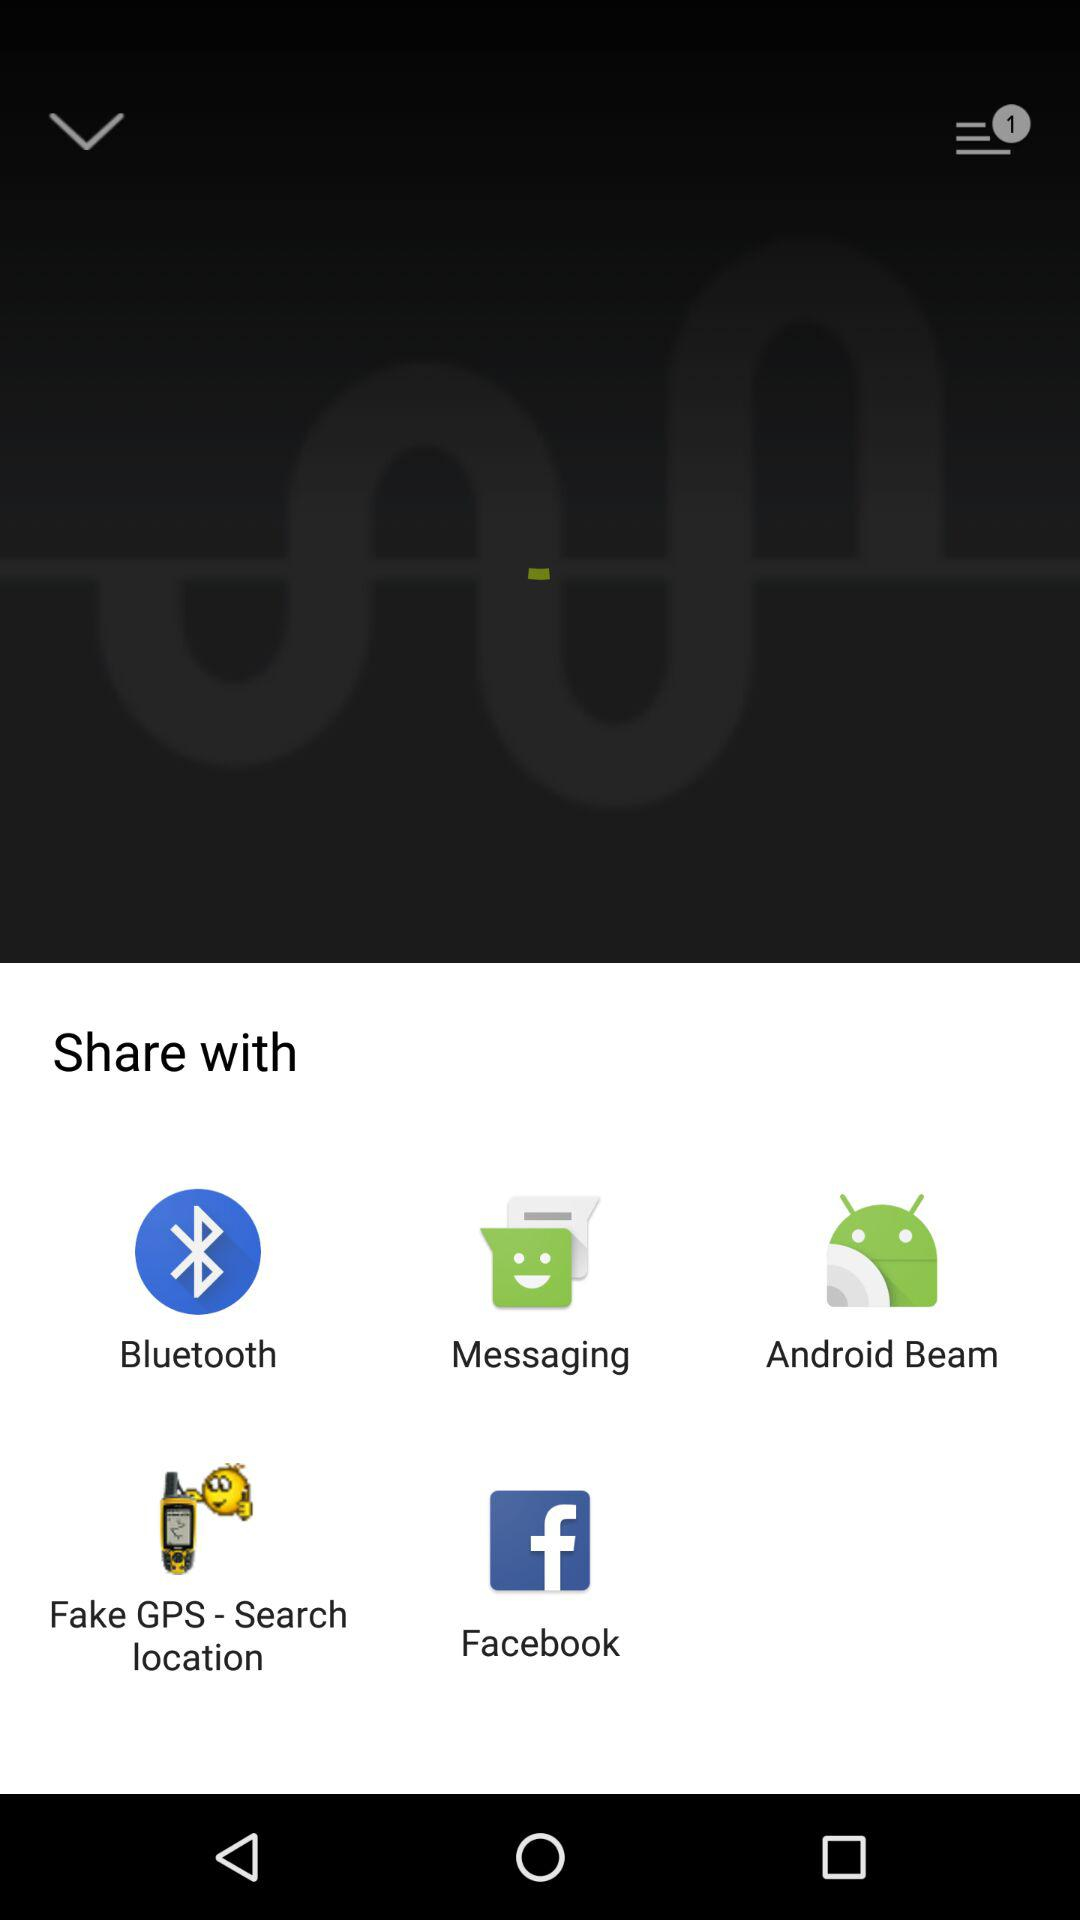What is the name of the application?
When the provided information is insufficient, respond with <no answer>. <no answer> 